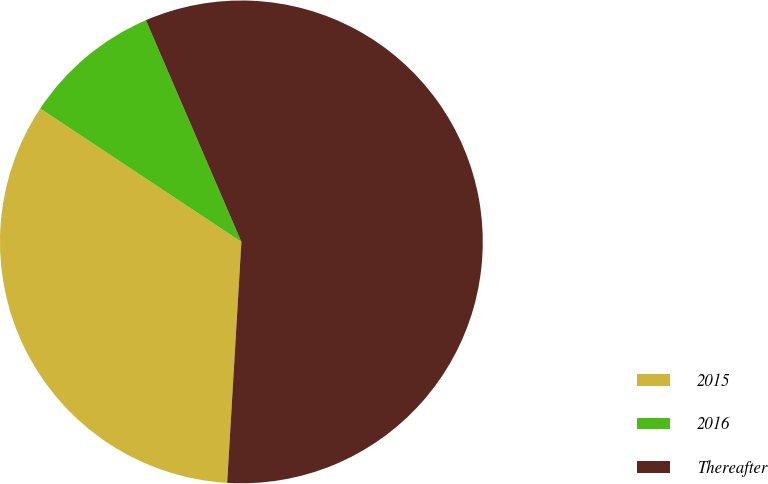<chart> <loc_0><loc_0><loc_500><loc_500><pie_chart><fcel>2015<fcel>2016<fcel>Thereafter<nl><fcel>33.38%<fcel>9.21%<fcel>57.41%<nl></chart> 